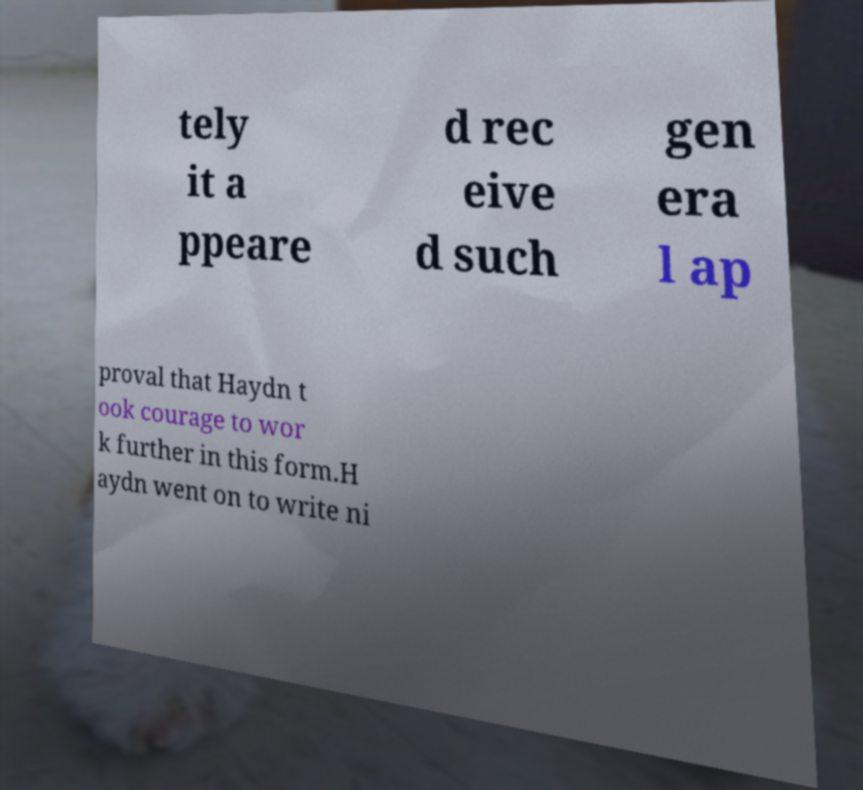Could you assist in decoding the text presented in this image and type it out clearly? tely it a ppeare d rec eive d such gen era l ap proval that Haydn t ook courage to wor k further in this form.H aydn went on to write ni 